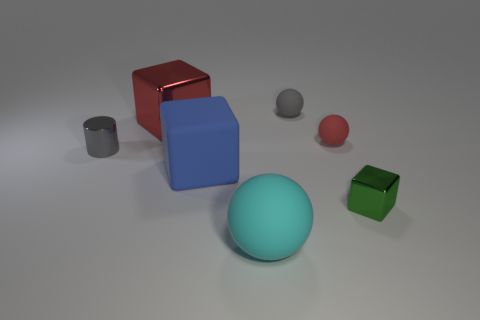Add 1 big blue metal cubes. How many objects exist? 8 Subtract all cylinders. How many objects are left? 6 Subtract all red rubber objects. Subtract all big cylinders. How many objects are left? 6 Add 4 blue matte things. How many blue matte things are left? 5 Add 4 big gray shiny balls. How many big gray shiny balls exist? 4 Subtract 1 cyan spheres. How many objects are left? 6 